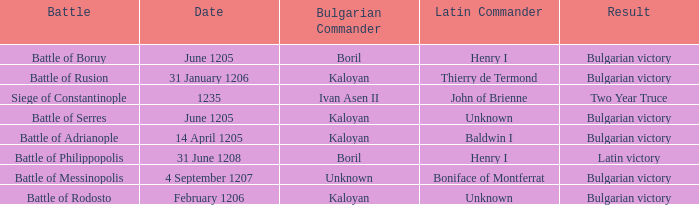What is the Result of the battle with Latin Commander Boniface of Montferrat? Bulgarian victory. 